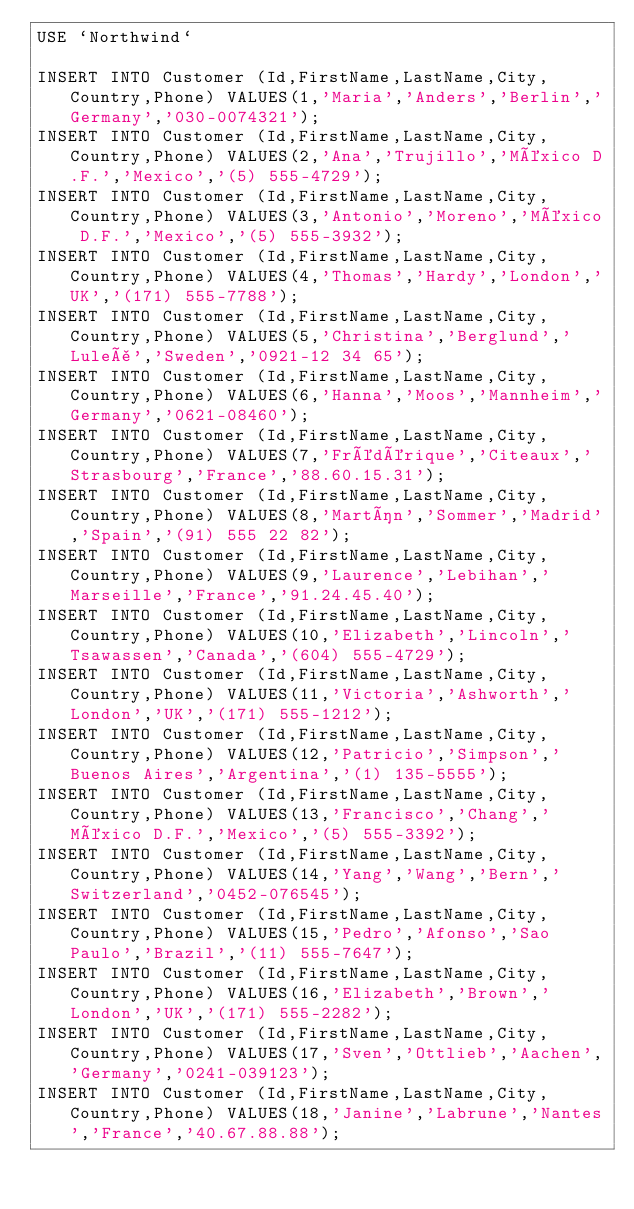Convert code to text. <code><loc_0><loc_0><loc_500><loc_500><_SQL_>USE `Northwind`

INSERT INTO Customer (Id,FirstName,LastName,City,Country,Phone) VALUES(1,'Maria','Anders','Berlin','Germany','030-0074321');
INSERT INTO Customer (Id,FirstName,LastName,City,Country,Phone) VALUES(2,'Ana','Trujillo','México D.F.','Mexico','(5) 555-4729');
INSERT INTO Customer (Id,FirstName,LastName,City,Country,Phone) VALUES(3,'Antonio','Moreno','México D.F.','Mexico','(5) 555-3932');
INSERT INTO Customer (Id,FirstName,LastName,City,Country,Phone) VALUES(4,'Thomas','Hardy','London','UK','(171) 555-7788');
INSERT INTO Customer (Id,FirstName,LastName,City,Country,Phone) VALUES(5,'Christina','Berglund','Luleå','Sweden','0921-12 34 65');
INSERT INTO Customer (Id,FirstName,LastName,City,Country,Phone) VALUES(6,'Hanna','Moos','Mannheim','Germany','0621-08460');
INSERT INTO Customer (Id,FirstName,LastName,City,Country,Phone) VALUES(7,'Frédérique','Citeaux','Strasbourg','France','88.60.15.31');
INSERT INTO Customer (Id,FirstName,LastName,City,Country,Phone) VALUES(8,'Martín','Sommer','Madrid','Spain','(91) 555 22 82');
INSERT INTO Customer (Id,FirstName,LastName,City,Country,Phone) VALUES(9,'Laurence','Lebihan','Marseille','France','91.24.45.40');
INSERT INTO Customer (Id,FirstName,LastName,City,Country,Phone) VALUES(10,'Elizabeth','Lincoln','Tsawassen','Canada','(604) 555-4729');
INSERT INTO Customer (Id,FirstName,LastName,City,Country,Phone) VALUES(11,'Victoria','Ashworth','London','UK','(171) 555-1212');
INSERT INTO Customer (Id,FirstName,LastName,City,Country,Phone) VALUES(12,'Patricio','Simpson','Buenos Aires','Argentina','(1) 135-5555');
INSERT INTO Customer (Id,FirstName,LastName,City,Country,Phone) VALUES(13,'Francisco','Chang','México D.F.','Mexico','(5) 555-3392');
INSERT INTO Customer (Id,FirstName,LastName,City,Country,Phone) VALUES(14,'Yang','Wang','Bern','Switzerland','0452-076545');
INSERT INTO Customer (Id,FirstName,LastName,City,Country,Phone) VALUES(15,'Pedro','Afonso','Sao Paulo','Brazil','(11) 555-7647');
INSERT INTO Customer (Id,FirstName,LastName,City,Country,Phone) VALUES(16,'Elizabeth','Brown','London','UK','(171) 555-2282');
INSERT INTO Customer (Id,FirstName,LastName,City,Country,Phone) VALUES(17,'Sven','Ottlieb','Aachen','Germany','0241-039123');
INSERT INTO Customer (Id,FirstName,LastName,City,Country,Phone) VALUES(18,'Janine','Labrune','Nantes','France','40.67.88.88');</code> 